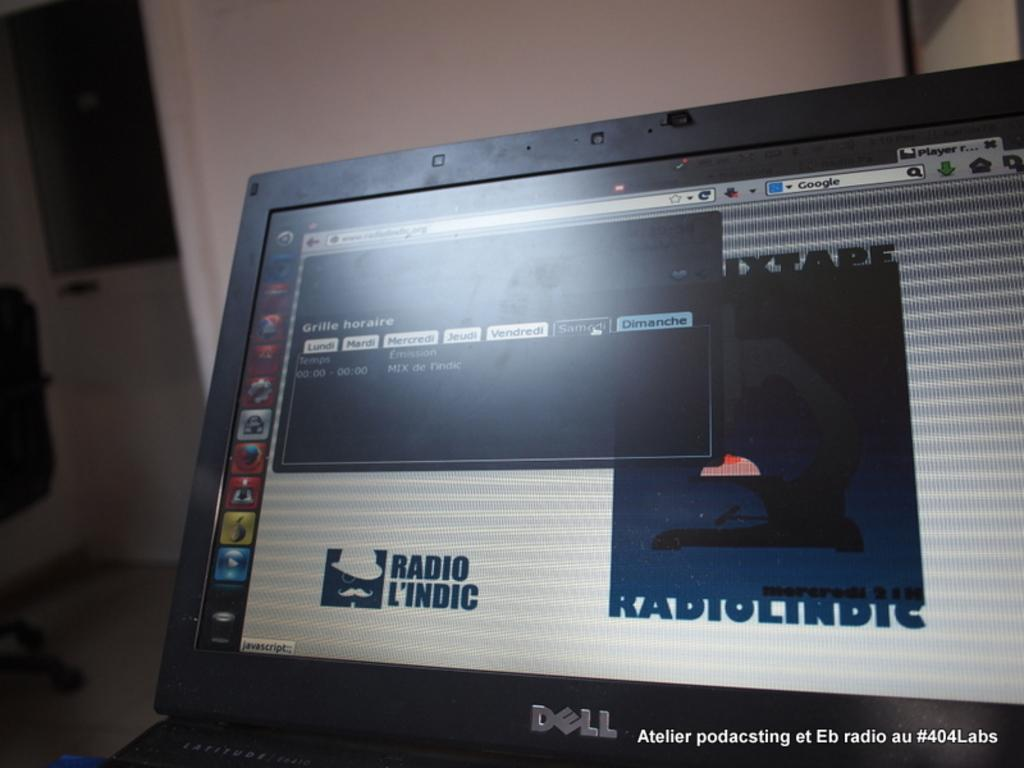<image>
Relay a brief, clear account of the picture shown. A laptop screen shows a website for Radio L'indic. 